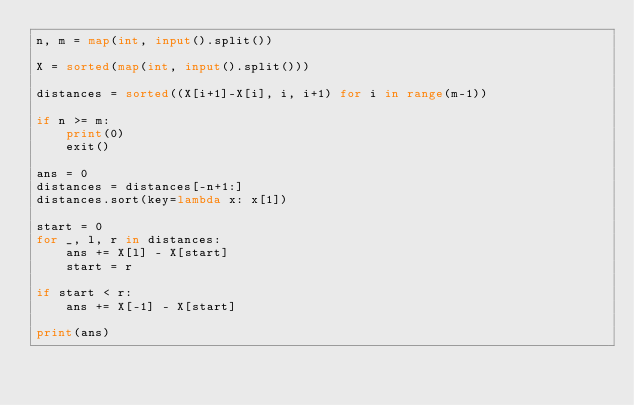Convert code to text. <code><loc_0><loc_0><loc_500><loc_500><_Python_>n, m = map(int, input().split())

X = sorted(map(int, input().split()))

distances = sorted((X[i+1]-X[i], i, i+1) for i in range(m-1))

if n >= m:
    print(0)
    exit()

ans = 0
distances = distances[-n+1:]
distances.sort(key=lambda x: x[1])

start = 0
for _, l, r in distances:
    ans += X[l] - X[start]
    start = r

if start < r:
    ans += X[-1] - X[start]

print(ans)</code> 